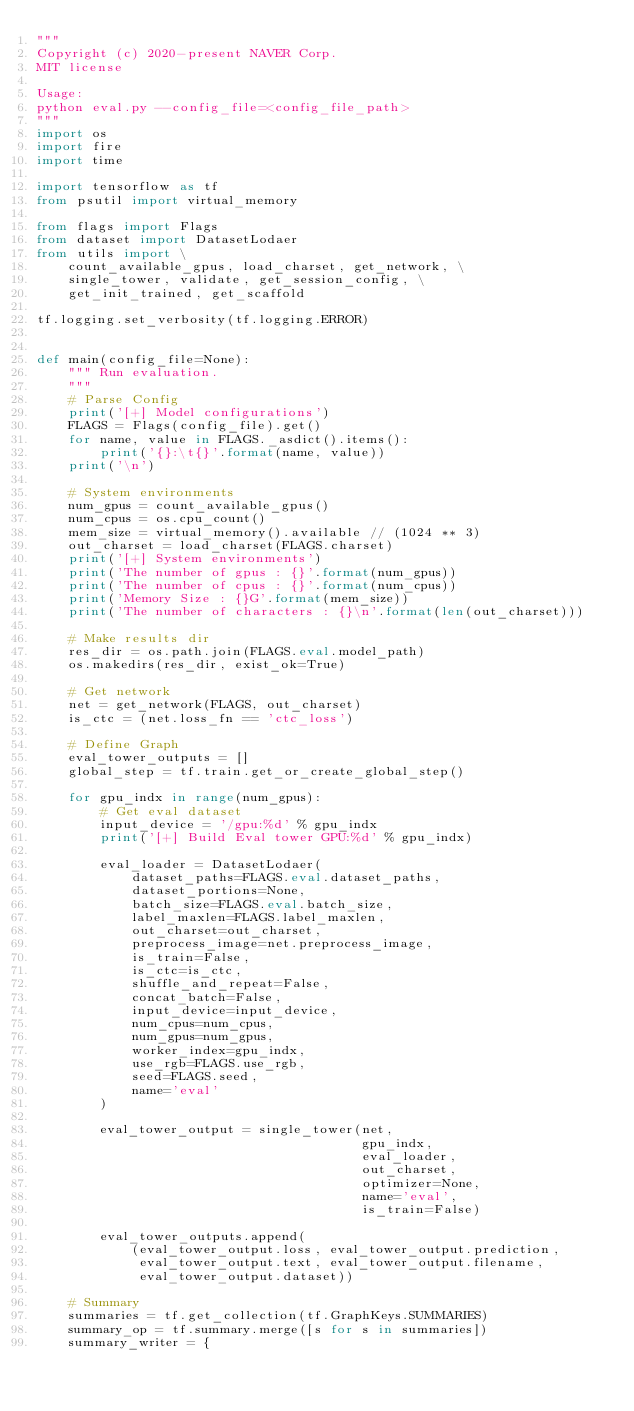<code> <loc_0><loc_0><loc_500><loc_500><_Python_>"""
Copyright (c) 2020-present NAVER Corp.
MIT license

Usage:
python eval.py --config_file=<config_file_path>
"""
import os
import fire
import time

import tensorflow as tf
from psutil import virtual_memory

from flags import Flags
from dataset import DatasetLodaer
from utils import \
    count_available_gpus, load_charset, get_network, \
    single_tower, validate, get_session_config, \
    get_init_trained, get_scaffold

tf.logging.set_verbosity(tf.logging.ERROR)


def main(config_file=None):
    """ Run evaluation.
    """
    # Parse Config
    print('[+] Model configurations')
    FLAGS = Flags(config_file).get()
    for name, value in FLAGS._asdict().items():
        print('{}:\t{}'.format(name, value))
    print('\n')

    # System environments
    num_gpus = count_available_gpus()
    num_cpus = os.cpu_count()
    mem_size = virtual_memory().available // (1024 ** 3)
    out_charset = load_charset(FLAGS.charset)
    print('[+] System environments')
    print('The number of gpus : {}'.format(num_gpus))
    print('The number of cpus : {}'.format(num_cpus))
    print('Memory Size : {}G'.format(mem_size))
    print('The number of characters : {}\n'.format(len(out_charset)))

    # Make results dir
    res_dir = os.path.join(FLAGS.eval.model_path)
    os.makedirs(res_dir, exist_ok=True)

    # Get network
    net = get_network(FLAGS, out_charset)
    is_ctc = (net.loss_fn == 'ctc_loss')

    # Define Graph
    eval_tower_outputs = []
    global_step = tf.train.get_or_create_global_step()

    for gpu_indx in range(num_gpus):
        # Get eval dataset
        input_device = '/gpu:%d' % gpu_indx
        print('[+] Build Eval tower GPU:%d' % gpu_indx)

        eval_loader = DatasetLodaer(
            dataset_paths=FLAGS.eval.dataset_paths,
            dataset_portions=None,
            batch_size=FLAGS.eval.batch_size,
            label_maxlen=FLAGS.label_maxlen,
            out_charset=out_charset,
            preprocess_image=net.preprocess_image,
            is_train=False,
            is_ctc=is_ctc,
            shuffle_and_repeat=False,
            concat_batch=False,
            input_device=input_device,
            num_cpus=num_cpus,
            num_gpus=num_gpus,
            worker_index=gpu_indx,
            use_rgb=FLAGS.use_rgb,
            seed=FLAGS.seed,
            name='eval'
        )

        eval_tower_output = single_tower(net,
                                         gpu_indx,
                                         eval_loader,
                                         out_charset,
                                         optimizer=None,
                                         name='eval',
                                         is_train=False)

        eval_tower_outputs.append(
            (eval_tower_output.loss, eval_tower_output.prediction,
             eval_tower_output.text, eval_tower_output.filename,
             eval_tower_output.dataset))

    # Summary
    summaries = tf.get_collection(tf.GraphKeys.SUMMARIES)
    summary_op = tf.summary.merge([s for s in summaries])
    summary_writer = {</code> 